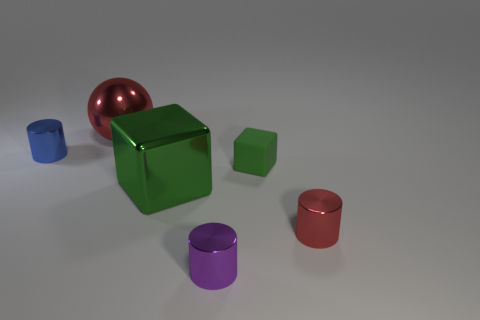Add 1 tiny yellow cylinders. How many objects exist? 7 Subtract all spheres. How many objects are left? 5 Subtract all tiny green metallic blocks. Subtract all tiny purple cylinders. How many objects are left? 5 Add 1 big shiny objects. How many big shiny objects are left? 3 Add 5 big brown matte objects. How many big brown matte objects exist? 5 Subtract 0 purple balls. How many objects are left? 6 